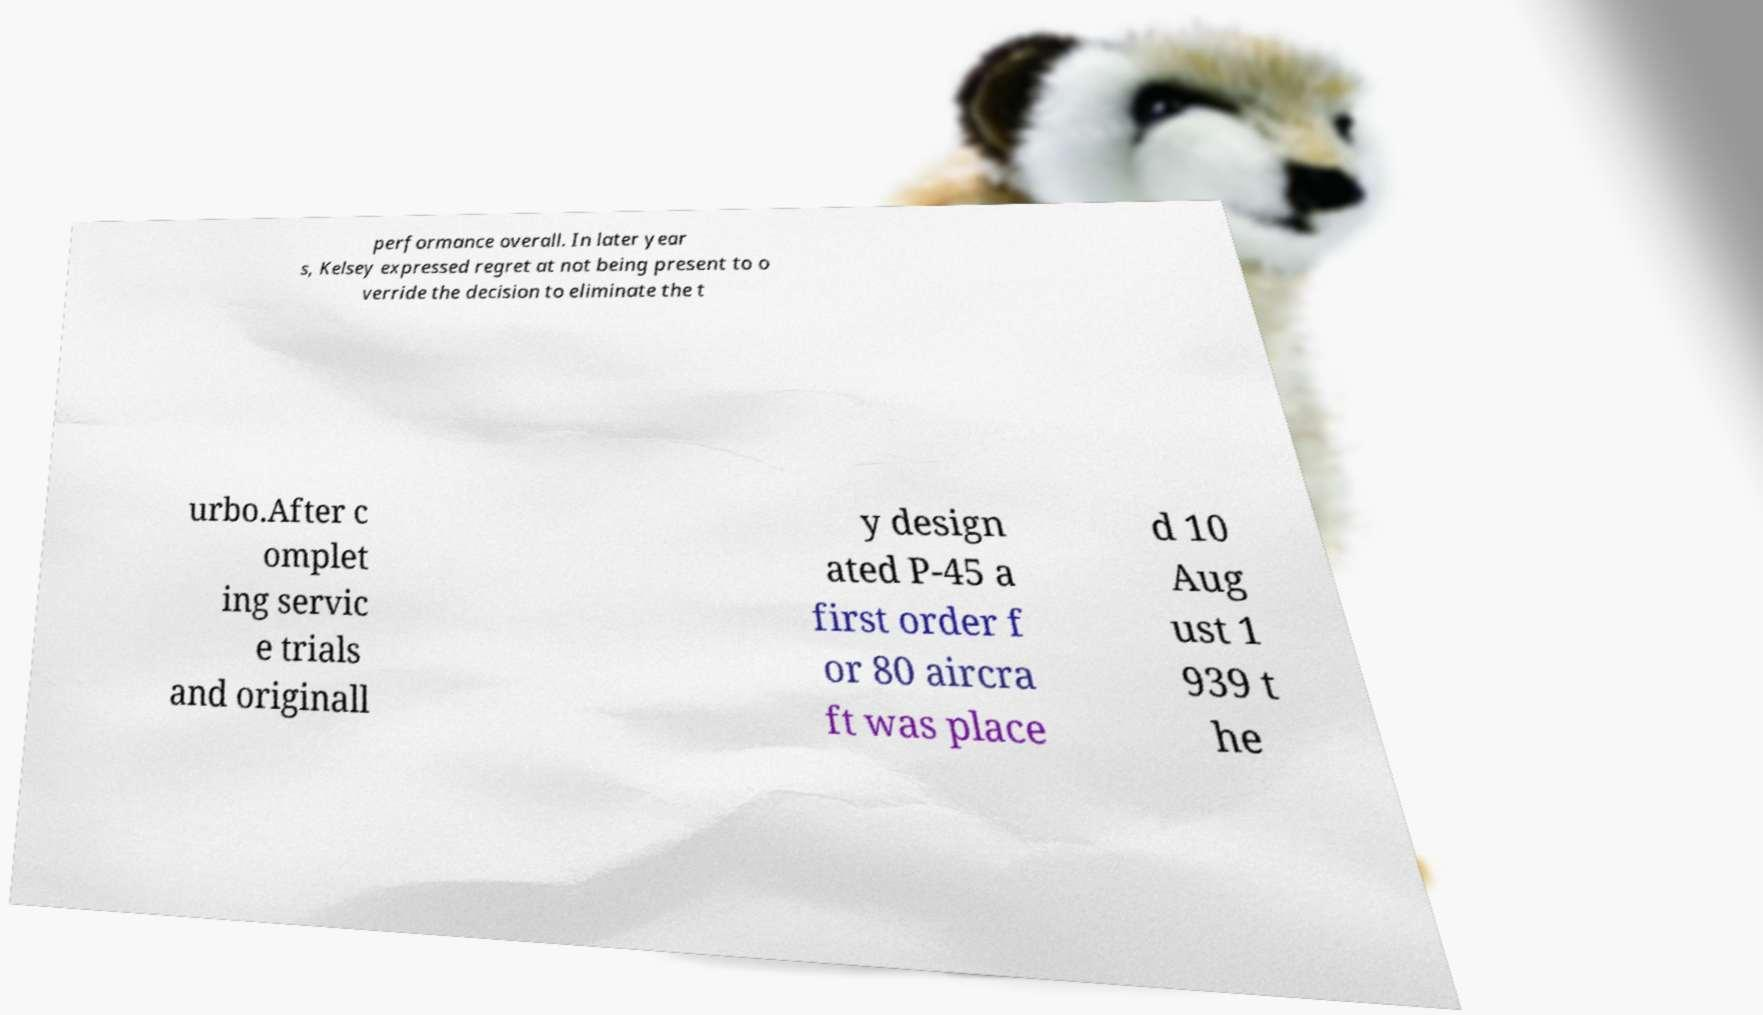Please read and relay the text visible in this image. What does it say? performance overall. In later year s, Kelsey expressed regret at not being present to o verride the decision to eliminate the t urbo.After c omplet ing servic e trials and originall y design ated P-45 a first order f or 80 aircra ft was place d 10 Aug ust 1 939 t he 